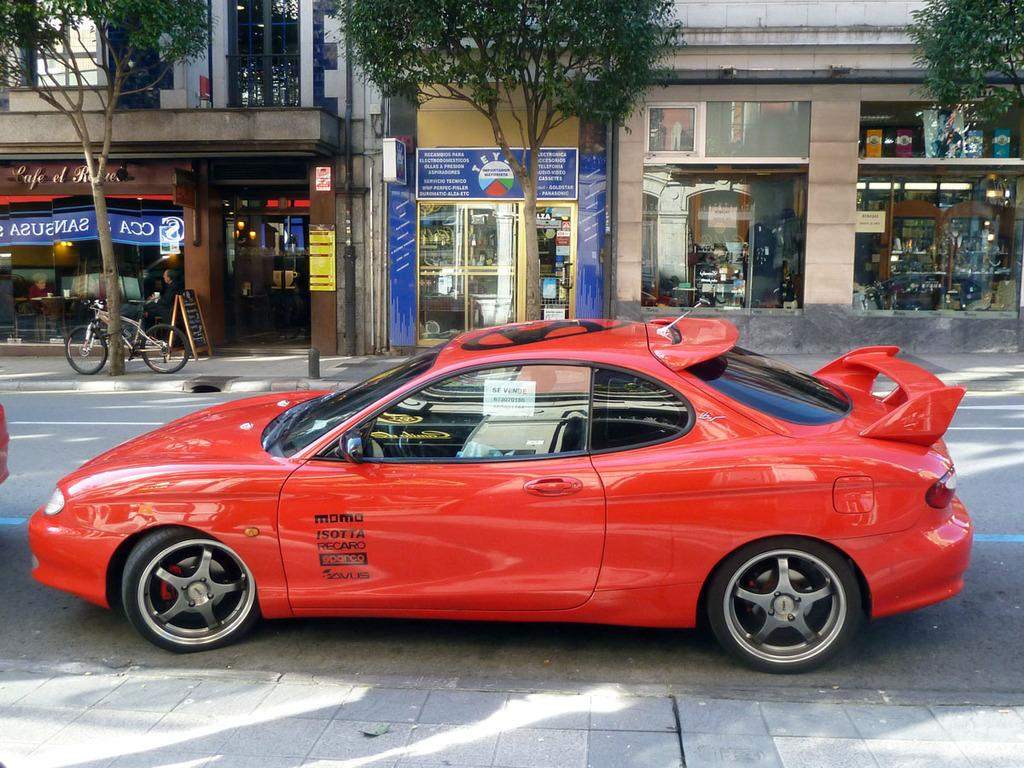What type of vehicle is in the image? There is a red car in the image. What can be seen in the background of the image? There is a road visible in the image. What type of establishments are present in the image? There are shops in the image. What type of vegetation is in the image? There are trees in the image. What other mode of transportation can be seen in the image? There is a bicycle in the image. What part of the brain can be seen in the image? There is no part of the brain present in the image. What type of fuel is being used by the red car in the image? The image does not provide information about the type of fuel being used by the red car. 